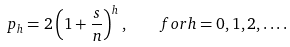<formula> <loc_0><loc_0><loc_500><loc_500>p _ { h } = 2 \left ( 1 + \frac { s } { n } \right ) ^ { h } , \quad f o r h = 0 , 1 , 2 , \dots .</formula> 